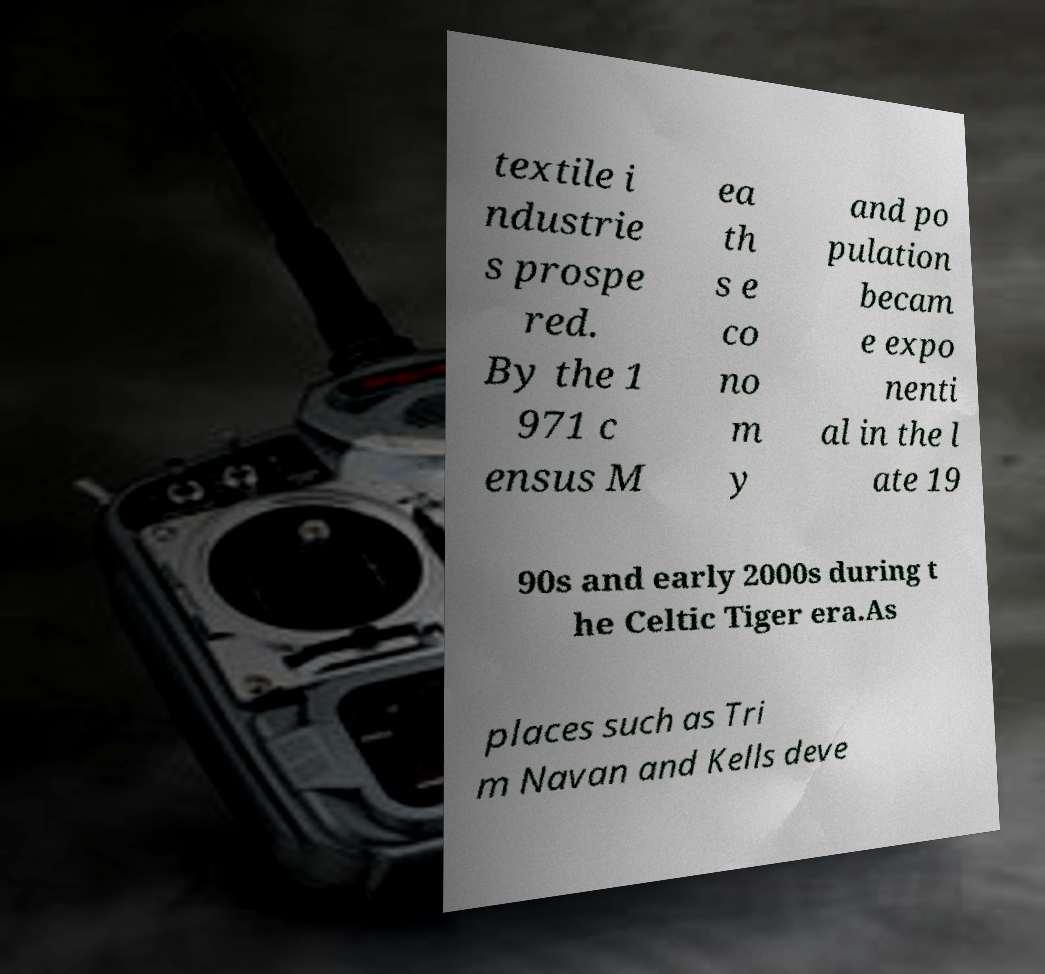Please identify and transcribe the text found in this image. textile i ndustrie s prospe red. By the 1 971 c ensus M ea th s e co no m y and po pulation becam e expo nenti al in the l ate 19 90s and early 2000s during t he Celtic Tiger era.As places such as Tri m Navan and Kells deve 